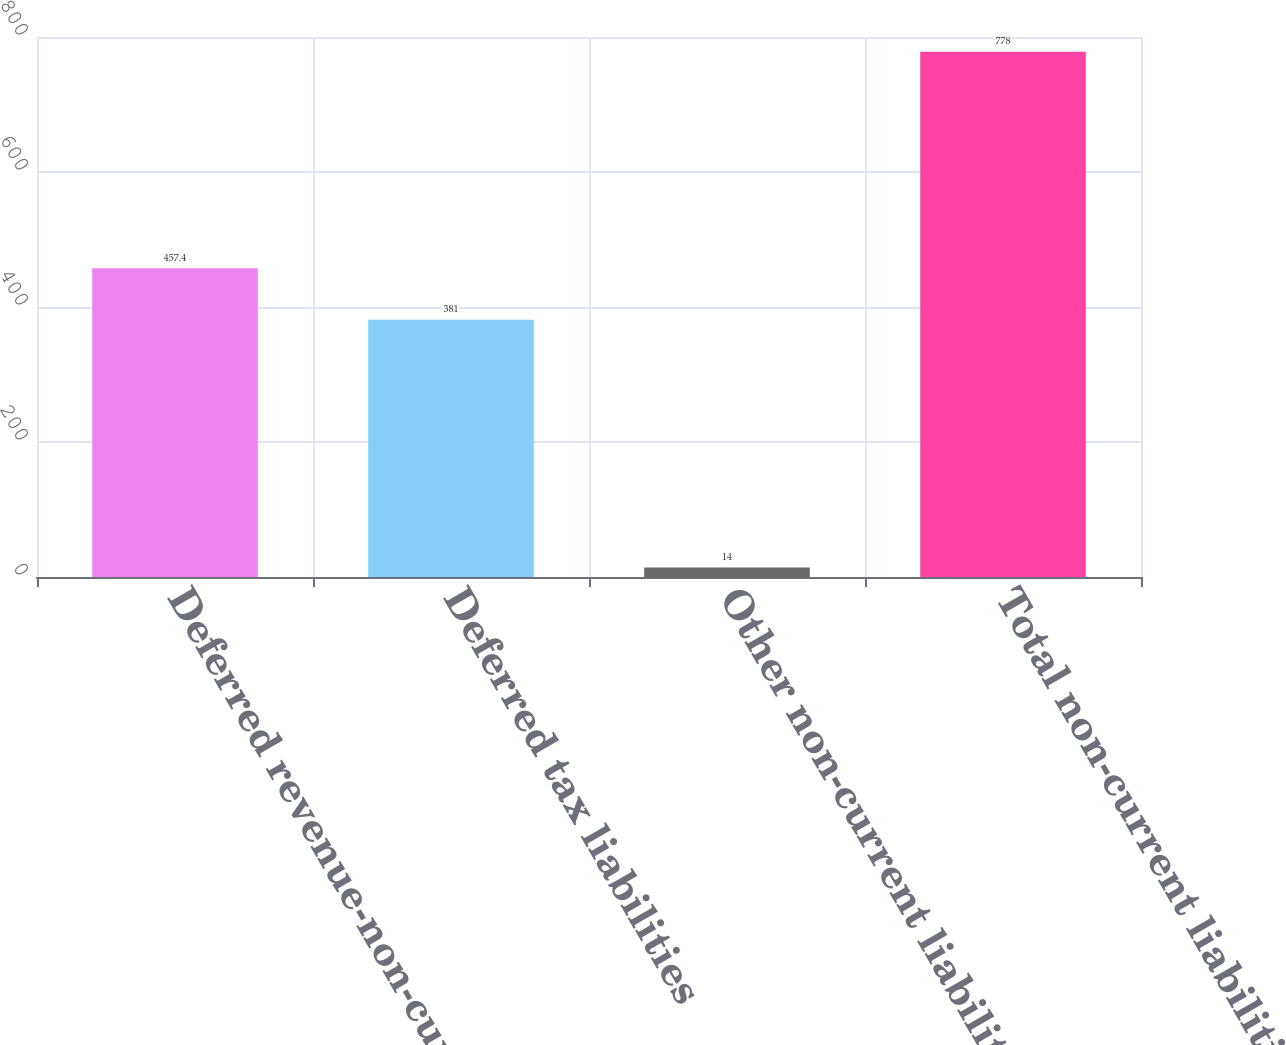<chart> <loc_0><loc_0><loc_500><loc_500><bar_chart><fcel>Deferred revenue-non-current<fcel>Deferred tax liabilities<fcel>Other non-current liabilities<fcel>Total non-current liabilities<nl><fcel>457.4<fcel>381<fcel>14<fcel>778<nl></chart> 